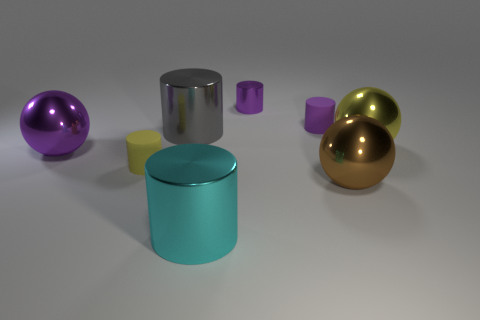Is the small cylinder right of the small metallic object made of the same material as the big gray object in front of the small purple metallic object?
Give a very brief answer. No. How many brown balls have the same size as the yellow rubber thing?
Provide a succinct answer. 0. What is the shape of the large shiny object that is the same color as the tiny metallic cylinder?
Give a very brief answer. Sphere. What is the material of the tiny cylinder that is in front of the big purple shiny sphere?
Ensure brevity in your answer.  Rubber. How many big gray things are the same shape as the large yellow metal thing?
Offer a very short reply. 0. What is the shape of the gray object that is the same material as the large yellow ball?
Your response must be concise. Cylinder. What shape is the tiny object that is behind the rubber thing behind the big cylinder to the left of the big cyan metallic cylinder?
Give a very brief answer. Cylinder. Is the number of gray things greater than the number of matte cylinders?
Offer a very short reply. No. There is a large cyan object that is the same shape as the small yellow matte object; what material is it?
Ensure brevity in your answer.  Metal. Are the yellow cylinder and the large cyan cylinder made of the same material?
Your response must be concise. No. 